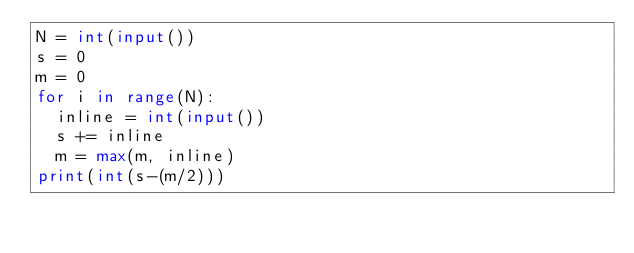<code> <loc_0><loc_0><loc_500><loc_500><_Python_>N = int(input())
s = 0
m = 0
for i in range(N):
  inline = int(input())
  s += inline
  m = max(m, inline)
print(int(s-(m/2)))</code> 